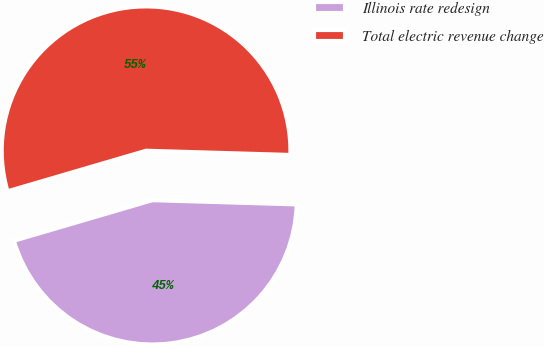Convert chart. <chart><loc_0><loc_0><loc_500><loc_500><pie_chart><fcel>Illinois rate redesign<fcel>Total electric revenue change<nl><fcel>45.0%<fcel>55.0%<nl></chart> 